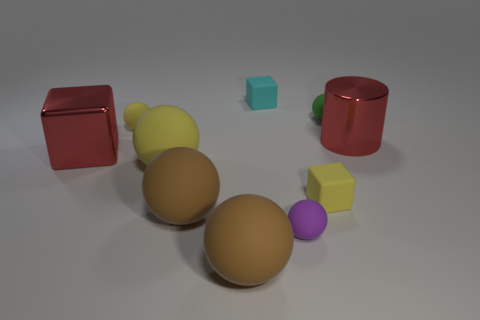Is the material of the red thing that is behind the large red metallic block the same as the sphere in front of the purple ball?
Provide a short and direct response. No. What number of things are big red metal objects or red shiny things that are right of the green sphere?
Your answer should be very brief. 2. Are there any other cyan matte objects that have the same shape as the tiny cyan object?
Keep it short and to the point. No. There is a yellow object on the right side of the large brown rubber thing that is on the right side of the brown matte thing that is behind the purple object; what is its size?
Provide a succinct answer. Small. Are there an equal number of large red metal cubes that are right of the yellow matte block and tiny purple things that are behind the small yellow rubber sphere?
Your answer should be very brief. Yes. What size is the block that is the same material as the big cylinder?
Ensure brevity in your answer.  Large. What color is the cylinder?
Offer a very short reply. Red. What number of metal objects have the same color as the cylinder?
Your answer should be compact. 1. There is a red object that is the same size as the red cube; what is its material?
Your answer should be very brief. Metal. There is a yellow sphere that is to the right of the small yellow ball; is there a yellow matte sphere behind it?
Your answer should be compact. Yes. 